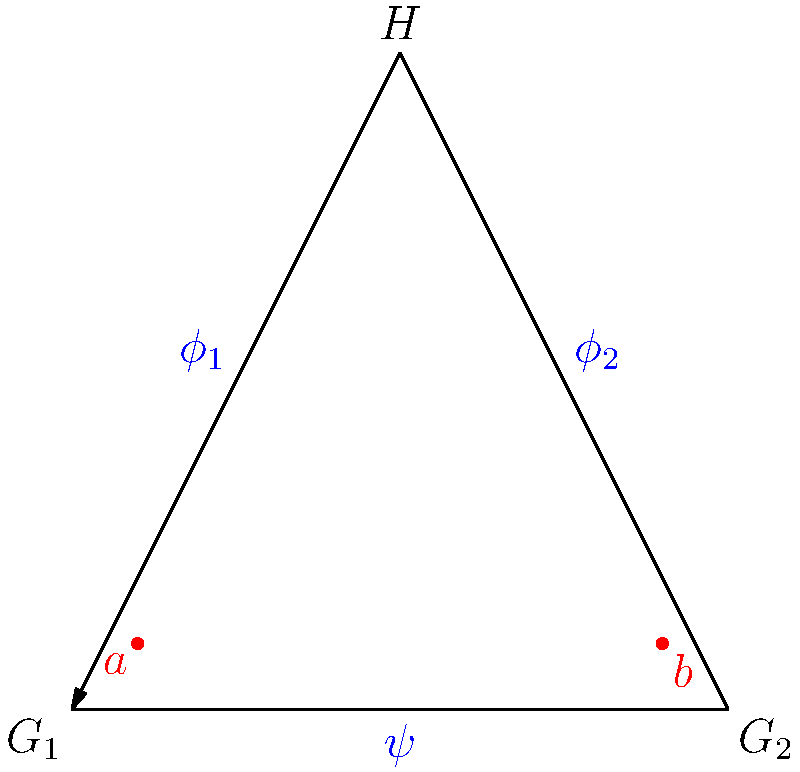Consider the group homomorphisms depicted in the arrow diagram above, where $\phi_1: G_1 \to H$, $\phi_2: G_2 \to H$, and $\psi: G_1 \to G_2$ are group homomorphisms. Given that $\phi_1(a) = \phi_2(b)$ for some elements $a \in G_1$ and $b \in G_2$, what can we conclude about the relationship between $\phi_1$, $\phi_2$, and $\psi$? Let's approach this step-by-step:

1) First, recall that for group homomorphisms to be compatible, they must satisfy certain conditions. In this case, we're looking for a relationship between $\phi_1$, $\phi_2$, and $\psi$.

2) We're given that $\phi_1(a) = \phi_2(b)$ for some $a \in G_1$ and $b \in G_2$. This suggests a connection between the images of $G_1$ and $G_2$ in $H$.

3) Now, consider the composition of $\phi_2$ and $\psi$. This would map elements from $G_1$ to $H$ through $G_2$.

4) If $\phi_2 \circ \psi = \phi_1$, then for any element $x \in G_1$:
   $\phi_2(\psi(x)) = \phi_1(x)$

5) In particular, for the element $a \in G_1$:
   $\phi_2(\psi(a)) = \phi_1(a)$

6) But we know that $\phi_1(a) = \phi_2(b)$, so:
   $\phi_2(\psi(a)) = \phi_2(b)$

7) Since $\phi_2$ is a homomorphism (and thus injective if it's an isomorphism), we can conclude:
   $\psi(a) = b$

8) This relationship holds for the specific elements $a$ and $b$, but it suggests a more general property: the diagram commutes.

9) In group theory, when a diagram commutes, it means that all paths between any two objects in the diagram are equivalent.

Therefore, we can conclude that the diagram is commutative, meaning $\phi_2 \circ \psi = \phi_1$.
Answer: The diagram is commutative: $\phi_2 \circ \psi = \phi_1$ 